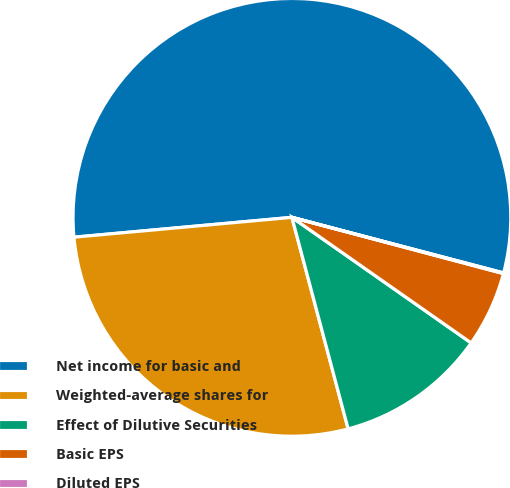Convert chart. <chart><loc_0><loc_0><loc_500><loc_500><pie_chart><fcel>Net income for basic and<fcel>Weighted-average shares for<fcel>Effect of Dilutive Securities<fcel>Basic EPS<fcel>Diluted EPS<nl><fcel>55.53%<fcel>27.69%<fcel>11.14%<fcel>5.59%<fcel>0.05%<nl></chart> 